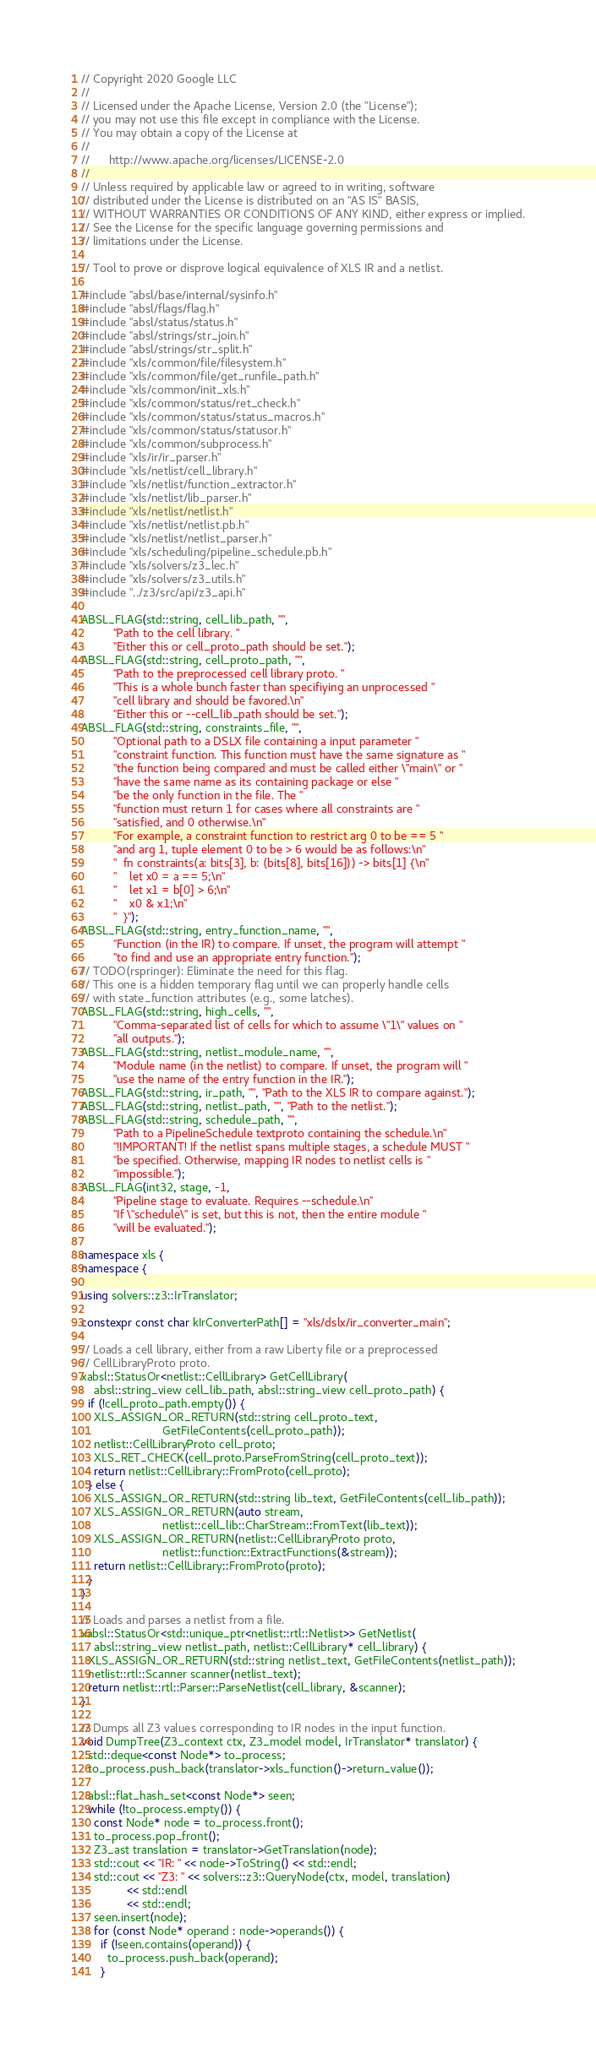Convert code to text. <code><loc_0><loc_0><loc_500><loc_500><_C++_>// Copyright 2020 Google LLC
//
// Licensed under the Apache License, Version 2.0 (the "License");
// you may not use this file except in compliance with the License.
// You may obtain a copy of the License at
//
//      http://www.apache.org/licenses/LICENSE-2.0
//
// Unless required by applicable law or agreed to in writing, software
// distributed under the License is distributed on an "AS IS" BASIS,
// WITHOUT WARRANTIES OR CONDITIONS OF ANY KIND, either express or implied.
// See the License for the specific language governing permissions and
// limitations under the License.

// Tool to prove or disprove logical equivalence of XLS IR and a netlist.

#include "absl/base/internal/sysinfo.h"
#include "absl/flags/flag.h"
#include "absl/status/status.h"
#include "absl/strings/str_join.h"
#include "absl/strings/str_split.h"
#include "xls/common/file/filesystem.h"
#include "xls/common/file/get_runfile_path.h"
#include "xls/common/init_xls.h"
#include "xls/common/status/ret_check.h"
#include "xls/common/status/status_macros.h"
#include "xls/common/status/statusor.h"
#include "xls/common/subprocess.h"
#include "xls/ir/ir_parser.h"
#include "xls/netlist/cell_library.h"
#include "xls/netlist/function_extractor.h"
#include "xls/netlist/lib_parser.h"
#include "xls/netlist/netlist.h"
#include "xls/netlist/netlist.pb.h"
#include "xls/netlist/netlist_parser.h"
#include "xls/scheduling/pipeline_schedule.pb.h"
#include "xls/solvers/z3_lec.h"
#include "xls/solvers/z3_utils.h"
#include "../z3/src/api/z3_api.h"

ABSL_FLAG(std::string, cell_lib_path, "",
          "Path to the cell library. "
          "Either this or cell_proto_path should be set.");
ABSL_FLAG(std::string, cell_proto_path, "",
          "Path to the preprocessed cell library proto. "
          "This is a whole bunch faster than specifiying an unprocessed "
          "cell library and should be favored.\n"
          "Either this or --cell_lib_path should be set.");
ABSL_FLAG(std::string, constraints_file, "",
          "Optional path to a DSLX file containing a input parameter "
          "constraint function. This function must have the same signature as "
          "the function being compared and must be called either \"main\" or "
          "have the same name as its containing package or else "
          "be the only function in the file. The "
          "function must return 1 for cases where all constraints are "
          "satisfied, and 0 otherwise.\n"
          "For example, a constraint function to restrict arg 0 to be == 5 "
          "and arg 1, tuple element 0 to be > 6 would be as follows:\n"
          "  fn constraints(a: bits[3], b: (bits[8], bits[16])) -> bits[1] {\n"
          "    let x0 = a == 5;\n"
          "    let x1 = b[0] > 6;\n"
          "    x0 & x1;\n"
          "  }");
ABSL_FLAG(std::string, entry_function_name, "",
          "Function (in the IR) to compare. If unset, the program will attempt "
          "to find and use an appropriate entry function.");
// TODO(rspringer): Eliminate the need for this flag.
// This one is a hidden temporary flag until we can properly handle cells
// with state_function attributes (e.g., some latches).
ABSL_FLAG(std::string, high_cells, "",
          "Comma-separated list of cells for which to assume \"1\" values on "
          "all outputs.");
ABSL_FLAG(std::string, netlist_module_name, "",
          "Module name (in the netlist) to compare. If unset, the program will "
          "use the name of the entry function in the IR.");
ABSL_FLAG(std::string, ir_path, "", "Path to the XLS IR to compare against.");
ABSL_FLAG(std::string, netlist_path, "", "Path to the netlist.");
ABSL_FLAG(std::string, schedule_path, "",
          "Path to a PipelineSchedule textproto containing the schedule.\n"
          "!IMPORTANT! If the netlist spans multiple stages, a schedule MUST "
          "be specified. Otherwise, mapping IR nodes to netlist cells is "
          "impossible.");
ABSL_FLAG(int32, stage, -1,
          "Pipeline stage to evaluate. Requires --schedule.\n"
          "If \"schedule\" is set, but this is not, then the entire module "
          "will be evaluated.");

namespace xls {
namespace {

using solvers::z3::IrTranslator;

constexpr const char kIrConverterPath[] = "xls/dslx/ir_converter_main";

// Loads a cell library, either from a raw Liberty file or a preprocessed
// CellLibraryProto proto.
xabsl::StatusOr<netlist::CellLibrary> GetCellLibrary(
    absl::string_view cell_lib_path, absl::string_view cell_proto_path) {
  if (!cell_proto_path.empty()) {
    XLS_ASSIGN_OR_RETURN(std::string cell_proto_text,
                         GetFileContents(cell_proto_path));
    netlist::CellLibraryProto cell_proto;
    XLS_RET_CHECK(cell_proto.ParseFromString(cell_proto_text));
    return netlist::CellLibrary::FromProto(cell_proto);
  } else {
    XLS_ASSIGN_OR_RETURN(std::string lib_text, GetFileContents(cell_lib_path));
    XLS_ASSIGN_OR_RETURN(auto stream,
                         netlist::cell_lib::CharStream::FromText(lib_text));
    XLS_ASSIGN_OR_RETURN(netlist::CellLibraryProto proto,
                         netlist::function::ExtractFunctions(&stream));
    return netlist::CellLibrary::FromProto(proto);
  }
}

// Loads and parses a netlist from a file.
xabsl::StatusOr<std::unique_ptr<netlist::rtl::Netlist>> GetNetlist(
    absl::string_view netlist_path, netlist::CellLibrary* cell_library) {
  XLS_ASSIGN_OR_RETURN(std::string netlist_text, GetFileContents(netlist_path));
  netlist::rtl::Scanner scanner(netlist_text);
  return netlist::rtl::Parser::ParseNetlist(cell_library, &scanner);
}

// Dumps all Z3 values corresponding to IR nodes in the input function.
void DumpTree(Z3_context ctx, Z3_model model, IrTranslator* translator) {
  std::deque<const Node*> to_process;
  to_process.push_back(translator->xls_function()->return_value());

  absl::flat_hash_set<const Node*> seen;
  while (!to_process.empty()) {
    const Node* node = to_process.front();
    to_process.pop_front();
    Z3_ast translation = translator->GetTranslation(node);
    std::cout << "IR: " << node->ToString() << std::endl;
    std::cout << "Z3: " << solvers::z3::QueryNode(ctx, model, translation)
              << std::endl
              << std::endl;
    seen.insert(node);
    for (const Node* operand : node->operands()) {
      if (!seen.contains(operand)) {
        to_process.push_back(operand);
      }</code> 